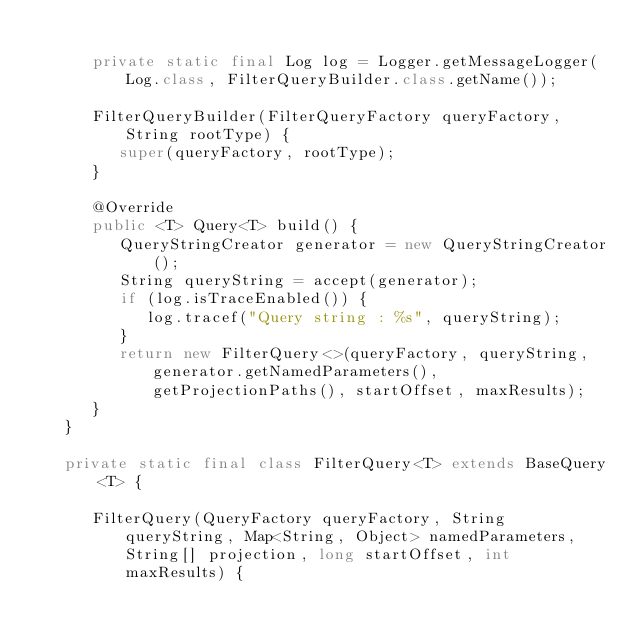<code> <loc_0><loc_0><loc_500><loc_500><_Java_>
      private static final Log log = Logger.getMessageLogger(Log.class, FilterQueryBuilder.class.getName());

      FilterQueryBuilder(FilterQueryFactory queryFactory, String rootType) {
         super(queryFactory, rootType);
      }

      @Override
      public <T> Query<T> build() {
         QueryStringCreator generator = new QueryStringCreator();
         String queryString = accept(generator);
         if (log.isTraceEnabled()) {
            log.tracef("Query string : %s", queryString);
         }
         return new FilterQuery<>(queryFactory, queryString, generator.getNamedParameters(), getProjectionPaths(), startOffset, maxResults);
      }
   }

   private static final class FilterQuery<T> extends BaseQuery<T> {

      FilterQuery(QueryFactory queryFactory, String queryString, Map<String, Object> namedParameters, String[] projection, long startOffset, int maxResults) {</code> 